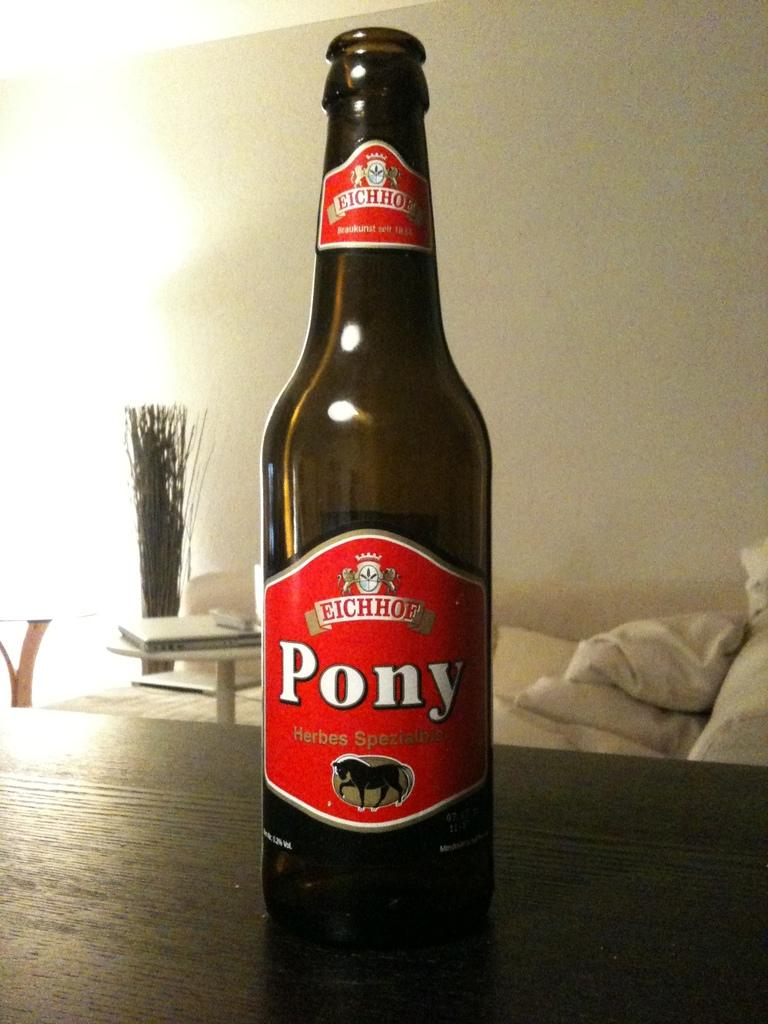What object is present in the image that is made of glass? There is a glass bottle in the image. What information can be found on the label of the glass bottle? The label has a pony's name on it. What is the background behind the glass bottle? There is a white wall behind the bottle. Can you see any fairies flying around the glass bottle in the image? There are no fairies present in the image. What type of teeth can be seen on the pony with the same name as the glass bottle? There is no pony present in the image, and therefore no teeth can be seen. 